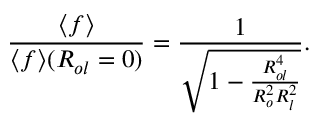<formula> <loc_0><loc_0><loc_500><loc_500>\frac { \langle f \rangle } { \langle f \rangle ( R _ { o l } = 0 ) } = \frac { 1 } { \sqrt { 1 - \frac { R _ { o l } ^ { 4 } } { R _ { o } ^ { 2 } R _ { l } ^ { 2 } } } } .</formula> 